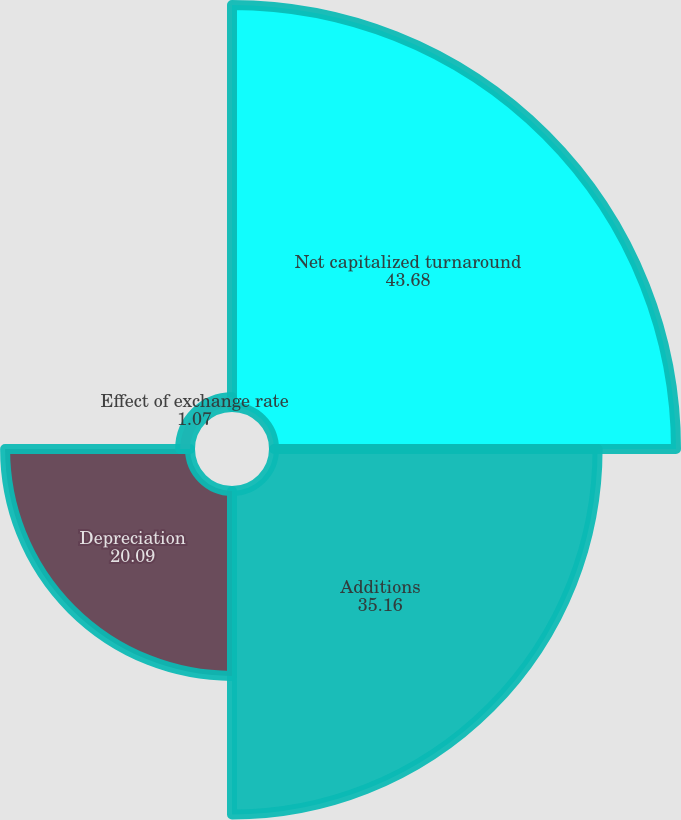Convert chart to OTSL. <chart><loc_0><loc_0><loc_500><loc_500><pie_chart><fcel>Net capitalized turnaround<fcel>Additions<fcel>Depreciation<fcel>Effect of exchange rate<nl><fcel>43.68%<fcel>35.16%<fcel>20.09%<fcel>1.07%<nl></chart> 